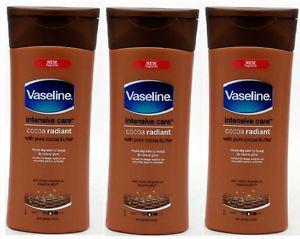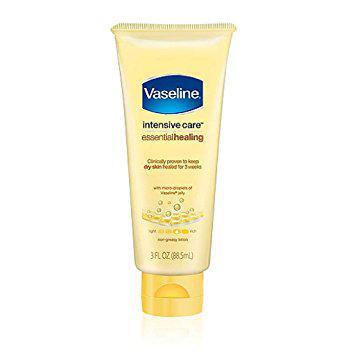The first image is the image on the left, the second image is the image on the right. Given the left and right images, does the statement "Some bottles of Vaseline are still in the package." hold true? Answer yes or no. No. The first image is the image on the left, the second image is the image on the right. Examine the images to the left and right. Is the description "The containers in the left image are all brown." accurate? Answer yes or no. Yes. 